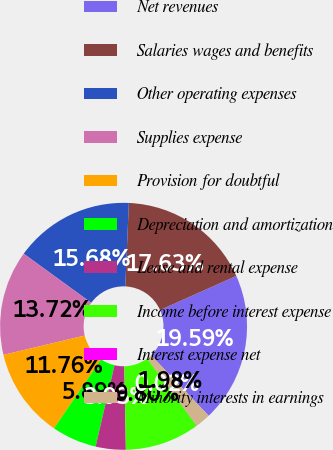Convert chart. <chart><loc_0><loc_0><loc_500><loc_500><pie_chart><fcel>Net revenues<fcel>Salaries wages and benefits<fcel>Other operating expenses<fcel>Supplies expense<fcel>Provision for doubtful<fcel>Depreciation and amortization<fcel>Lease and rental expense<fcel>Income before interest expense<fcel>Interest expense net<fcel>Minority interests in earnings<nl><fcel>19.59%<fcel>17.63%<fcel>15.68%<fcel>13.72%<fcel>11.76%<fcel>5.89%<fcel>3.93%<fcel>9.8%<fcel>0.02%<fcel>1.98%<nl></chart> 